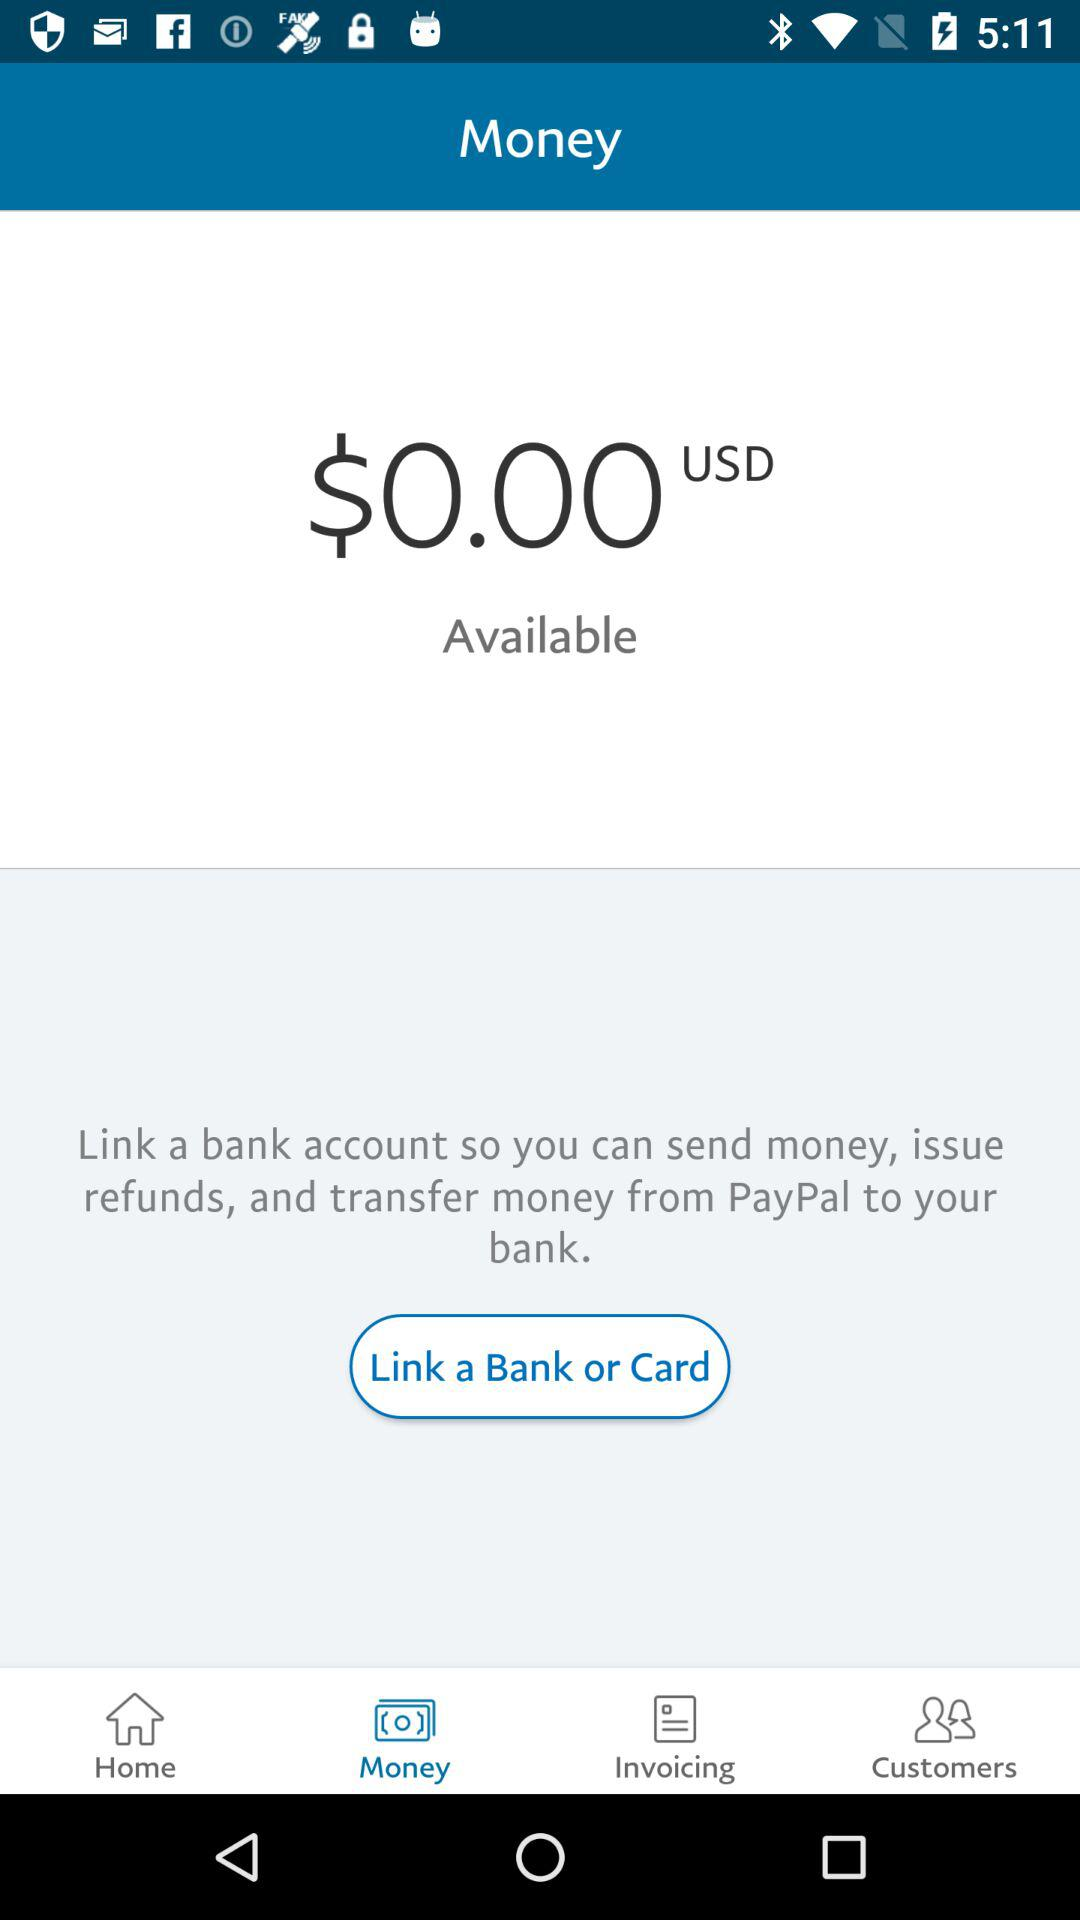How much money is available?
Answer the question using a single word or phrase. $0.00 